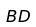<formula> <loc_0><loc_0><loc_500><loc_500>B D</formula> 